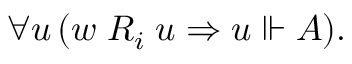Convert formula to latex. <formula><loc_0><loc_0><loc_500><loc_500>\forall u \, ( w \, R _ { i } \, u \Rightarrow u \ V d a s h A ) .</formula> 